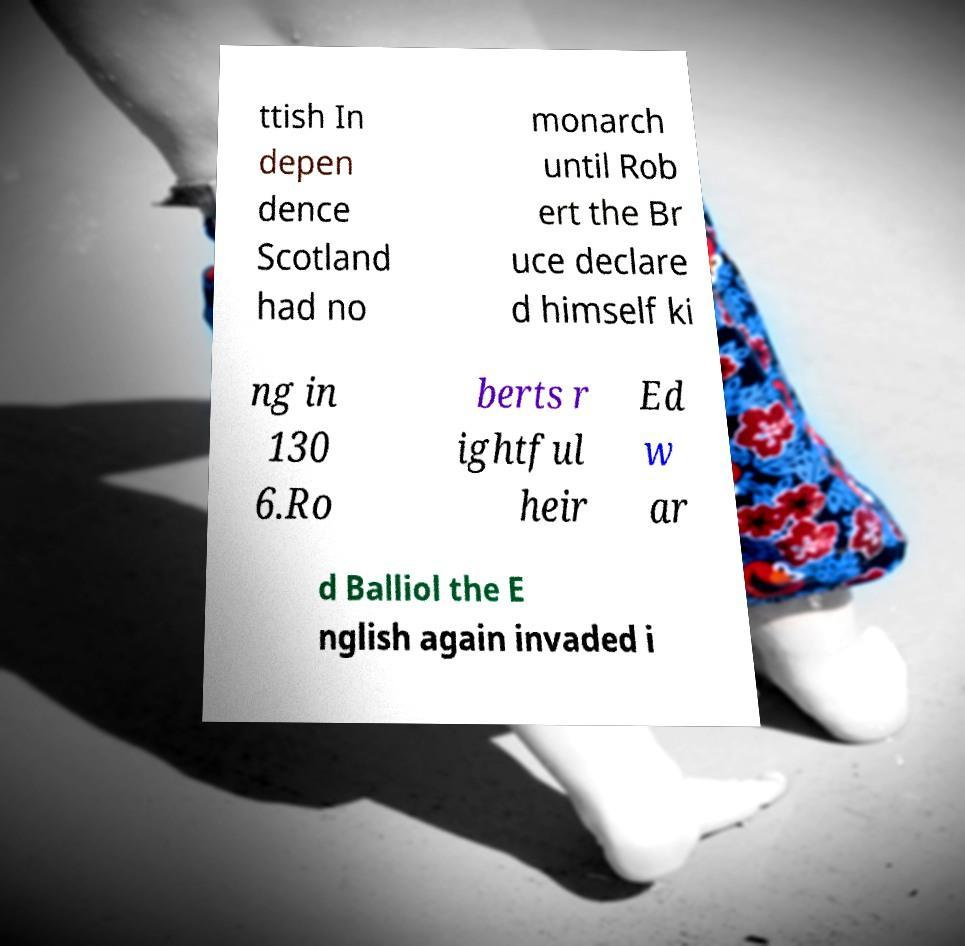Can you accurately transcribe the text from the provided image for me? ttish In depen dence Scotland had no monarch until Rob ert the Br uce declare d himself ki ng in 130 6.Ro berts r ightful heir Ed w ar d Balliol the E nglish again invaded i 